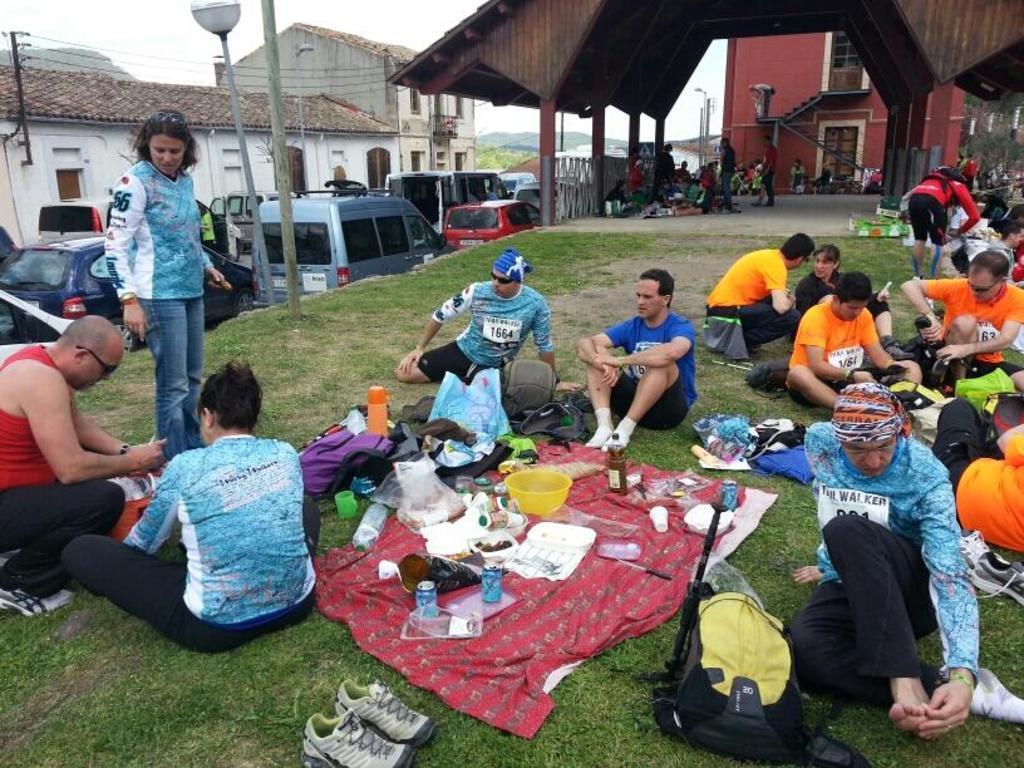Could you give a brief overview of what you see in this image? In this image I can see number of persons are sitting on the ground, some grass on the ground, a pair of footwear, a bed sheet which is red in color and on the bed sheet I can see few bottles, few cups, a bowl and few other objects. In the background I can see few vehicles on the road, few buildings, few stairs, few persons standing, few windows, few poles and the sky. 